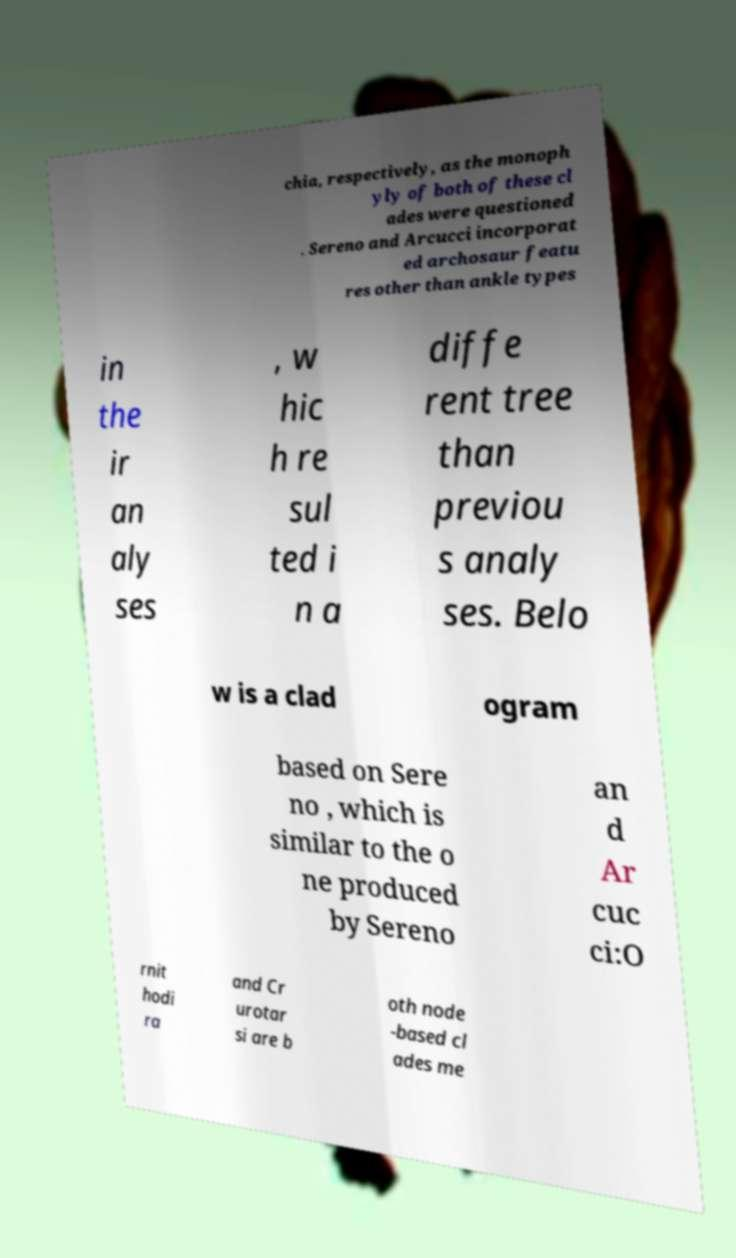Could you assist in decoding the text presented in this image and type it out clearly? chia, respectively, as the monoph yly of both of these cl ades were questioned . Sereno and Arcucci incorporat ed archosaur featu res other than ankle types in the ir an aly ses , w hic h re sul ted i n a diffe rent tree than previou s analy ses. Belo w is a clad ogram based on Sere no , which is similar to the o ne produced by Sereno an d Ar cuc ci:O rnit hodi ra and Cr urotar si are b oth node -based cl ades me 